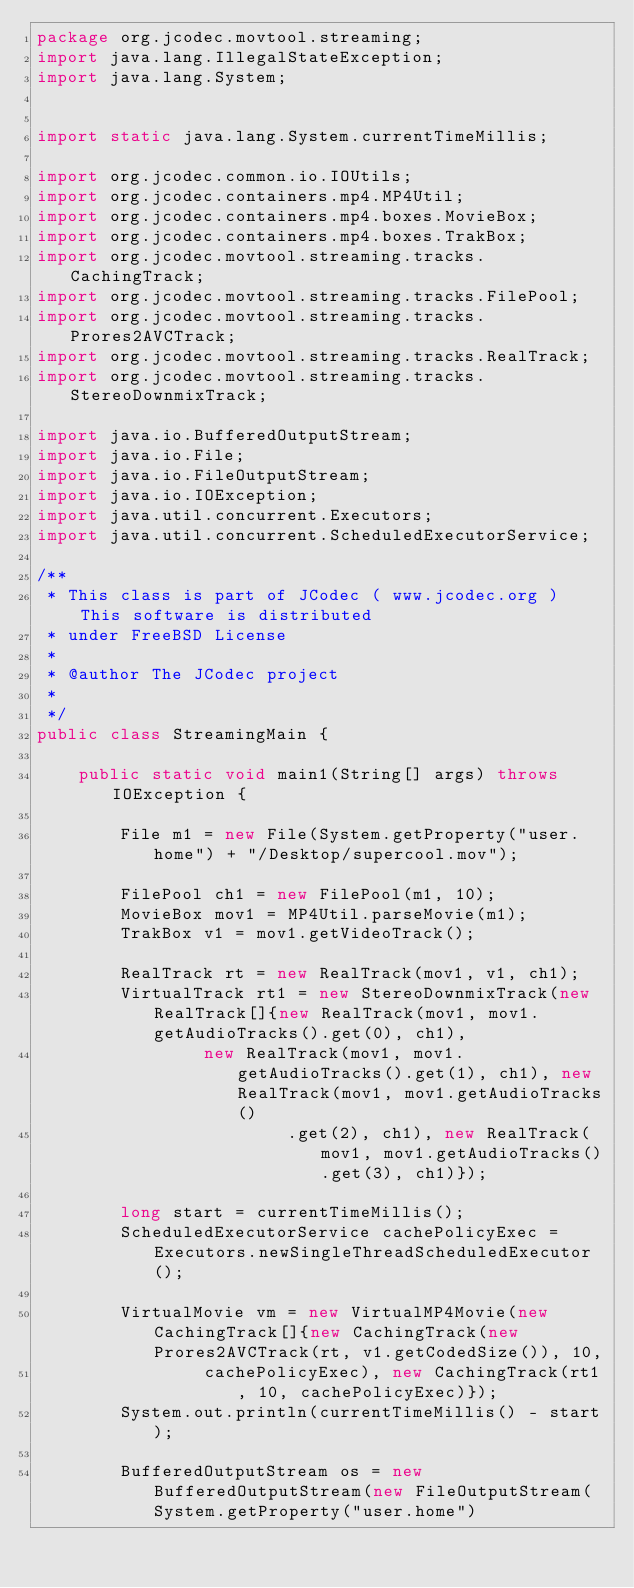<code> <loc_0><loc_0><loc_500><loc_500><_Java_>package org.jcodec.movtool.streaming;
import java.lang.IllegalStateException;
import java.lang.System;


import static java.lang.System.currentTimeMillis;

import org.jcodec.common.io.IOUtils;
import org.jcodec.containers.mp4.MP4Util;
import org.jcodec.containers.mp4.boxes.MovieBox;
import org.jcodec.containers.mp4.boxes.TrakBox;
import org.jcodec.movtool.streaming.tracks.CachingTrack;
import org.jcodec.movtool.streaming.tracks.FilePool;
import org.jcodec.movtool.streaming.tracks.Prores2AVCTrack;
import org.jcodec.movtool.streaming.tracks.RealTrack;
import org.jcodec.movtool.streaming.tracks.StereoDownmixTrack;

import java.io.BufferedOutputStream;
import java.io.File;
import java.io.FileOutputStream;
import java.io.IOException;
import java.util.concurrent.Executors;
import java.util.concurrent.ScheduledExecutorService;

/**
 * This class is part of JCodec ( www.jcodec.org ) This software is distributed
 * under FreeBSD License
 * 
 * @author The JCodec project
 * 
 */
public class StreamingMain {

    public static void main1(String[] args) throws IOException {

        File m1 = new File(System.getProperty("user.home") + "/Desktop/supercool.mov");

        FilePool ch1 = new FilePool(m1, 10);
        MovieBox mov1 = MP4Util.parseMovie(m1);
        TrakBox v1 = mov1.getVideoTrack();

        RealTrack rt = new RealTrack(mov1, v1, ch1);
        VirtualTrack rt1 = new StereoDownmixTrack(new RealTrack[]{new RealTrack(mov1, mov1.getAudioTracks().get(0), ch1),
                new RealTrack(mov1, mov1.getAudioTracks().get(1), ch1), new RealTrack(mov1, mov1.getAudioTracks()
                        .get(2), ch1), new RealTrack(mov1, mov1.getAudioTracks().get(3), ch1)});

        long start = currentTimeMillis();
        ScheduledExecutorService cachePolicyExec = Executors.newSingleThreadScheduledExecutor();

        VirtualMovie vm = new VirtualMP4Movie(new CachingTrack[]{new CachingTrack(new Prores2AVCTrack(rt, v1.getCodedSize()), 10,
                cachePolicyExec), new CachingTrack(rt1, 10, cachePolicyExec)});
        System.out.println(currentTimeMillis() - start);

        BufferedOutputStream os = new BufferedOutputStream(new FileOutputStream(System.getProperty("user.home")</code> 